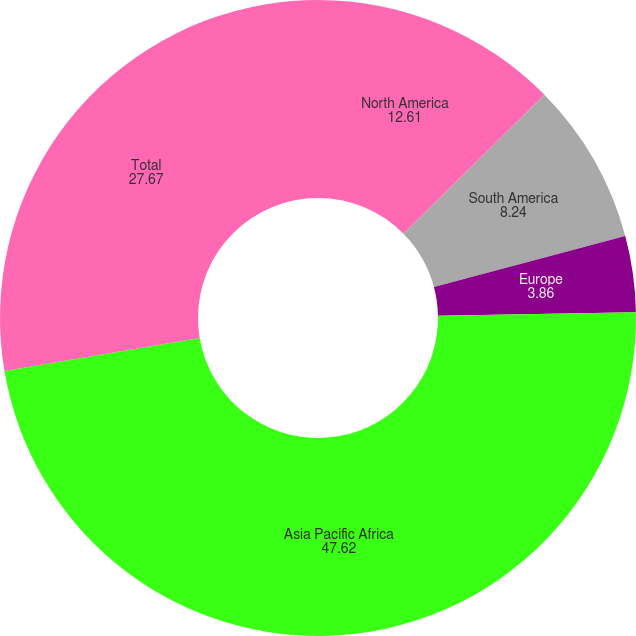Convert chart. <chart><loc_0><loc_0><loc_500><loc_500><pie_chart><fcel>North America<fcel>South America<fcel>Europe<fcel>Asia Pacific Africa<fcel>Total<nl><fcel>12.61%<fcel>8.24%<fcel>3.86%<fcel>47.62%<fcel>27.67%<nl></chart> 